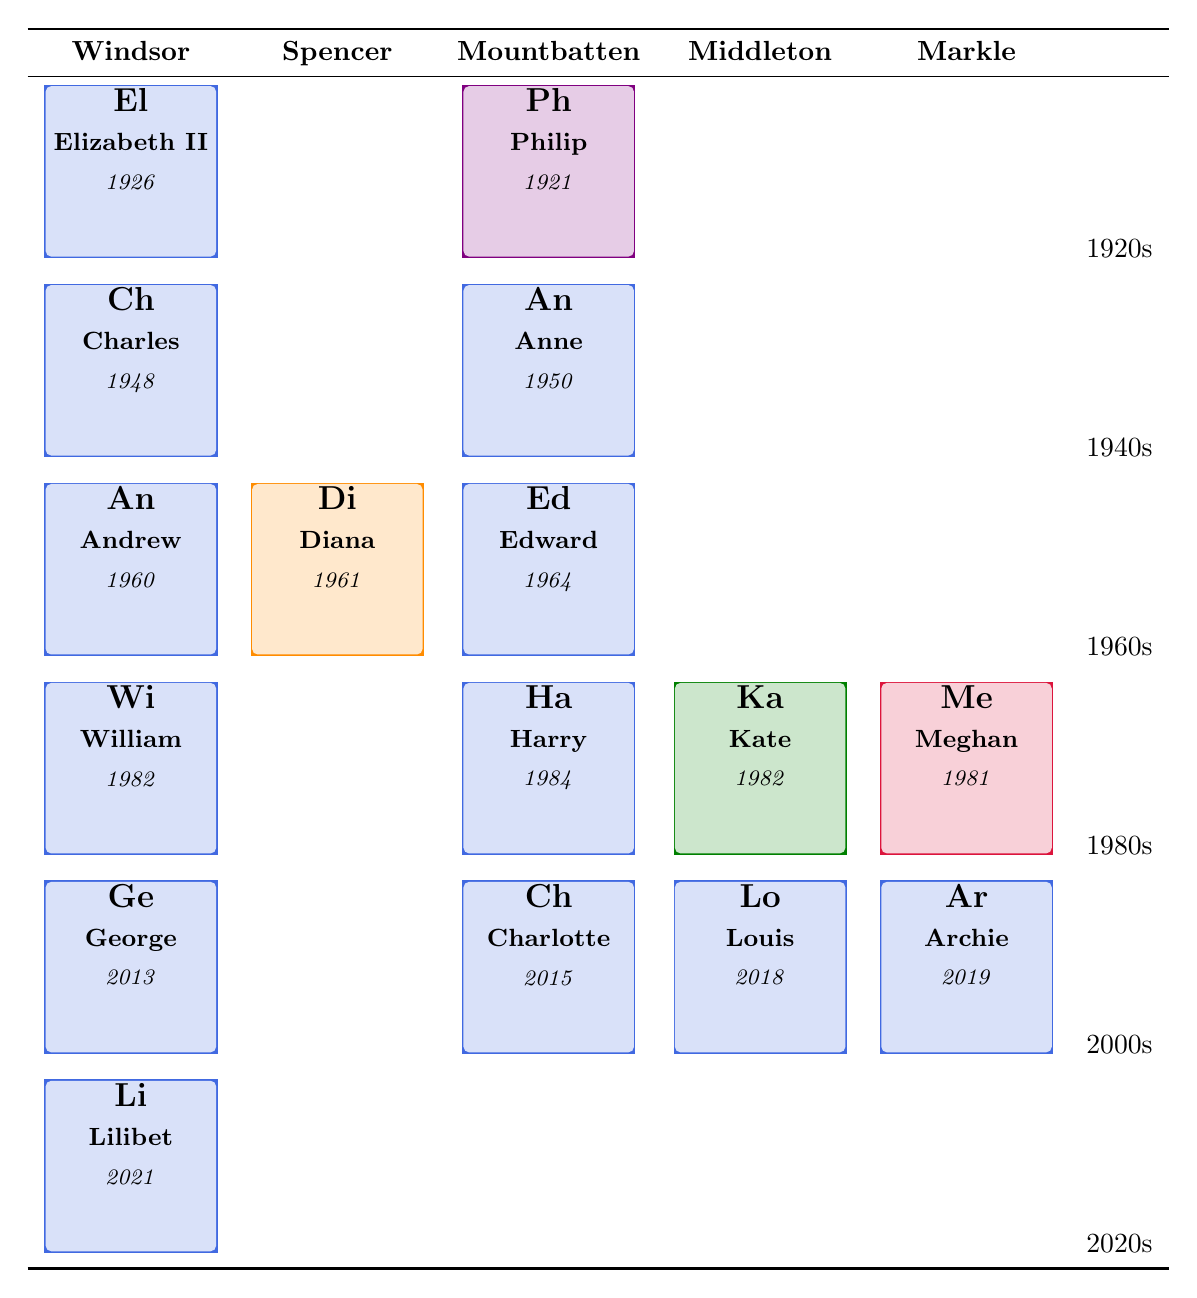What is the birth year of Elizabeth II? The table shows the element for Elizabeth II with the birth year listed next to her name. Referring to the table, her birth year is 1926.
Answer: 1926 How many royal family members were born in the 1980s? From the table, I see three members born in the 1980s: William (1982), Harry (1984), and Meghan (1981). Counting these, there are three members.
Answer: 3 Did any members of the Windsor family have a child born in the 2010s? The table shows that George (2013), Charlotte (2015), Louis (2018), and Archie (2019) are all from the Windsor family. Since they are all listed under the Windsor group, this statement is true.
Answer: Yes Who is the youngest royal family member listed? I first look at the years in the final row. The last member listed is Lilibet, born in 2021, which is the latest year among all listed members. Therefore, Lilibet is the youngest member.
Answer: Lilibet What is the average birth year of all members born in the 2000s? I first identify the members born in the 2000s: George (2013), Charlotte (2015), Louis (2018), and Archie (2019). The sum of their birth years is 2013 + 2015 + 2018 + 2019 = 8075. There are four members, so I divide the total by 4: 8075 / 4 = 2018.75. Rounding down gives 2018, the average birth year is therefore 2018.
Answer: 2018 